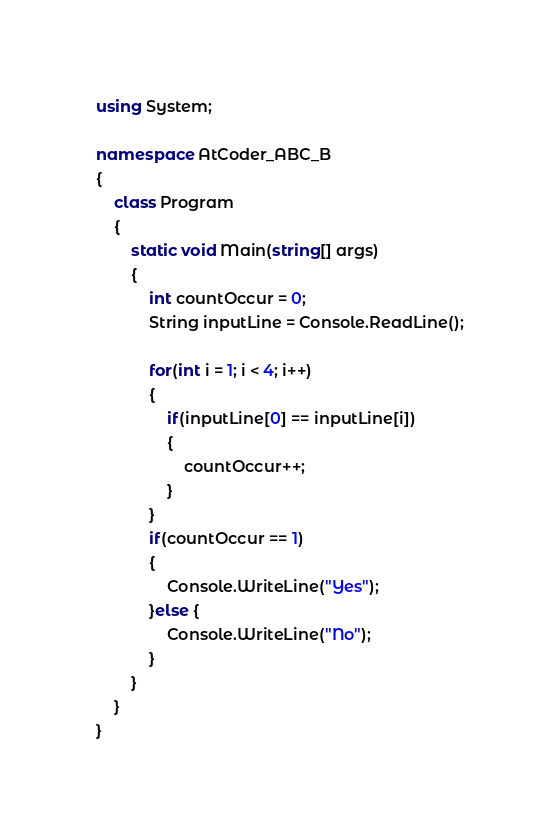<code> <loc_0><loc_0><loc_500><loc_500><_C#_>using System;

namespace AtCoder_ABC_B
{
    class Program
    {
        static void Main(string[] args)
        {
            int countOccur = 0;
            String inputLine = Console.ReadLine();

            for(int i = 1; i < 4; i++)
            {
                if(inputLine[0] == inputLine[i])
                {
                    countOccur++;
                }
            }
            if(countOccur == 1)
            {
                Console.WriteLine("Yes");
            }else {
                Console.WriteLine("No");
            }
        }
    }
}
</code> 